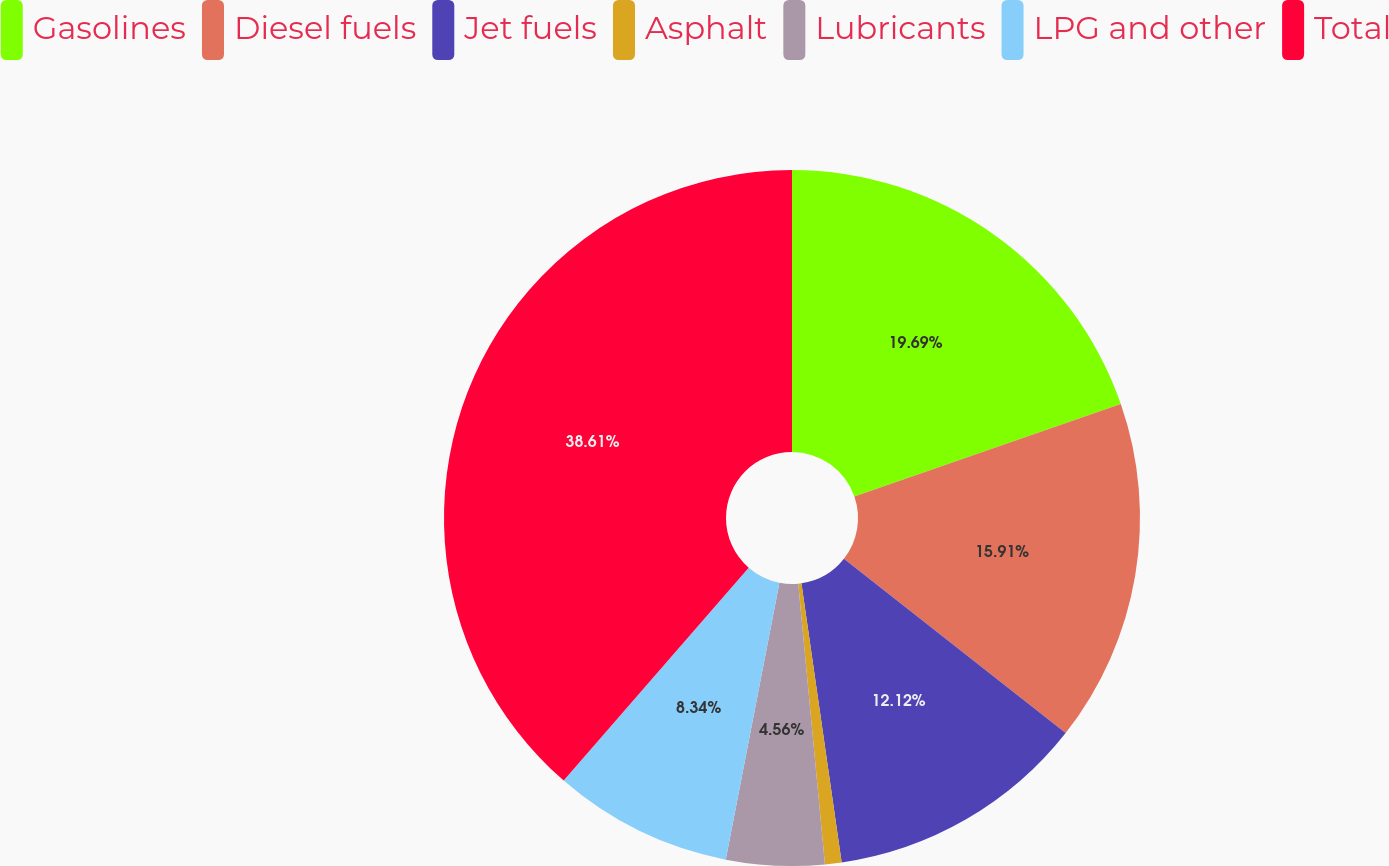Convert chart. <chart><loc_0><loc_0><loc_500><loc_500><pie_chart><fcel>Gasolines<fcel>Diesel fuels<fcel>Jet fuels<fcel>Asphalt<fcel>Lubricants<fcel>LPG and other<fcel>Total<nl><fcel>19.69%<fcel>15.91%<fcel>12.12%<fcel>0.77%<fcel>4.56%<fcel>8.34%<fcel>38.61%<nl></chart> 